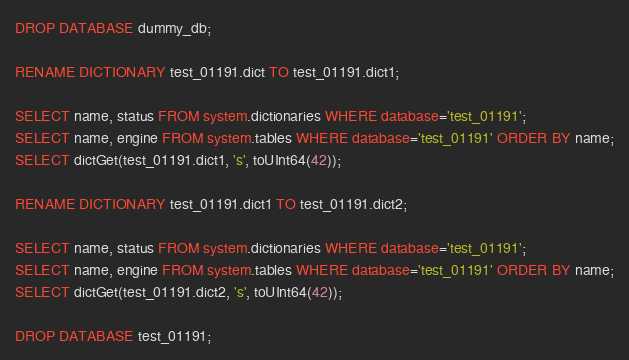Convert code to text. <code><loc_0><loc_0><loc_500><loc_500><_SQL_>DROP DATABASE dummy_db;

RENAME DICTIONARY test_01191.dict TO test_01191.dict1;

SELECT name, status FROM system.dictionaries WHERE database='test_01191';
SELECT name, engine FROM system.tables WHERE database='test_01191' ORDER BY name;
SELECT dictGet(test_01191.dict1, 's', toUInt64(42));

RENAME DICTIONARY test_01191.dict1 TO test_01191.dict2;

SELECT name, status FROM system.dictionaries WHERE database='test_01191';
SELECT name, engine FROM system.tables WHERE database='test_01191' ORDER BY name;
SELECT dictGet(test_01191.dict2, 's', toUInt64(42));

DROP DATABASE test_01191;
</code> 